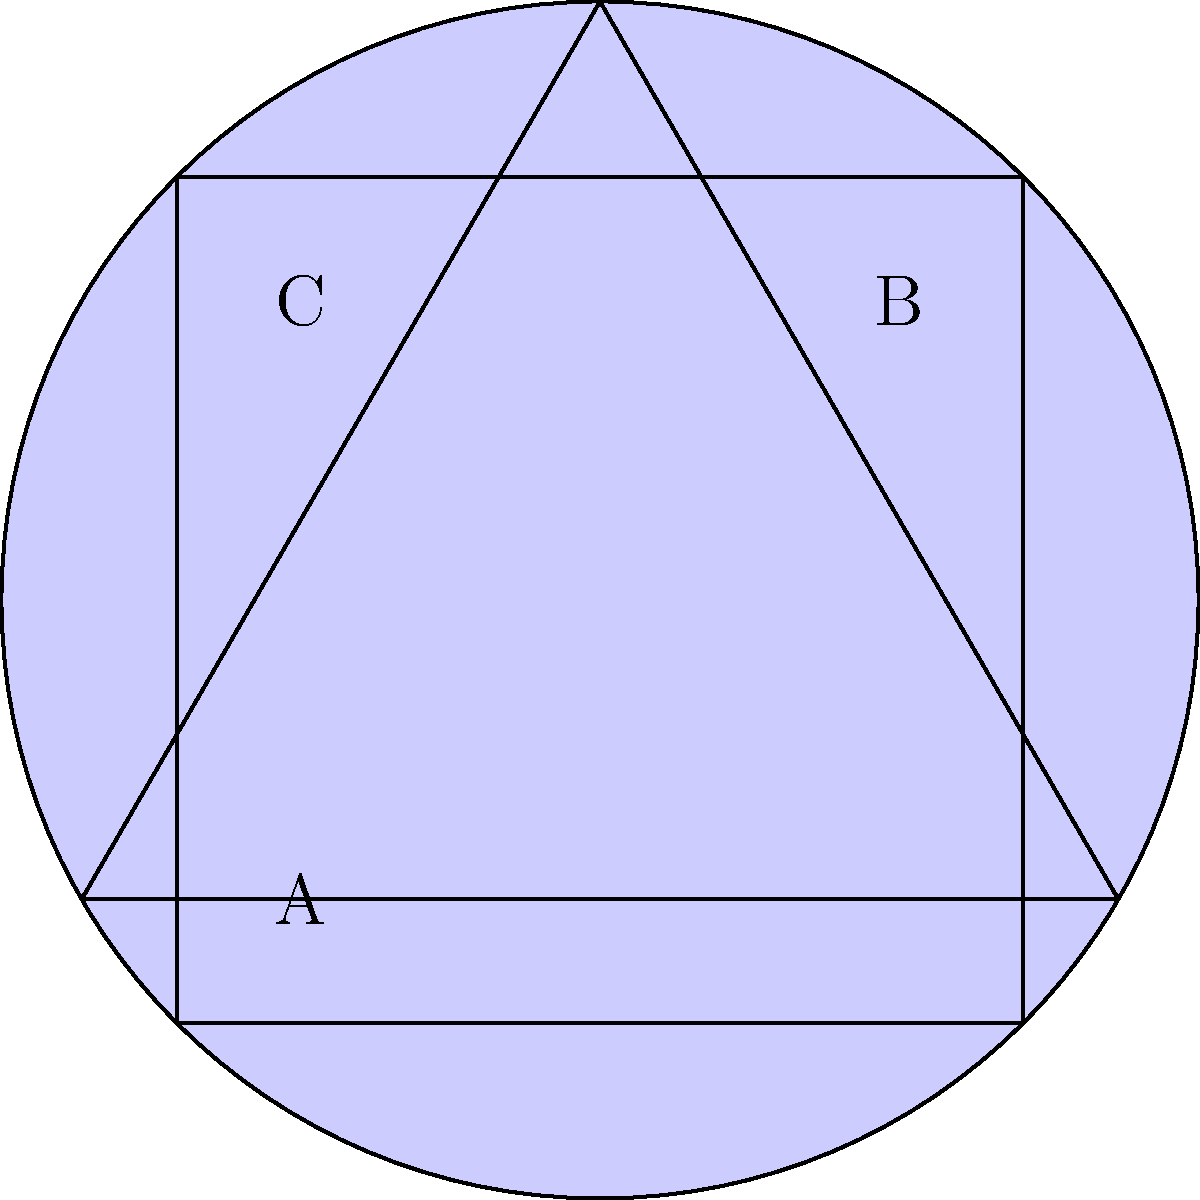In the image above, three geometric shapes (a triangle, a square, and a circle) are overlapping. How many distinct regions are formed by the overlapping shapes? To determine the number of distinct regions, we need to analyze the overlapping areas systematically:

1. First, identify the shapes: triangle, square, and circle.

2. Count the non-overlapping regions:
   - Triangle only: 1 region
   - Square only: 1 region
   - Circle only: 1 region

3. Count the regions where two shapes overlap:
   - Triangle and square: 1 region
   - Triangle and circle: 1 region
   - Square and circle: 1 region

4. Count the region where all three shapes overlap:
   - Triangle, square, and circle: 1 region

5. Sum up all the distinct regions:
   3 (non-overlapping) + 3 (two-shape overlap) + 1 (three-shape overlap) = 7 regions

Therefore, the total number of distinct regions formed by the overlapping shapes is 7.
Answer: 7 